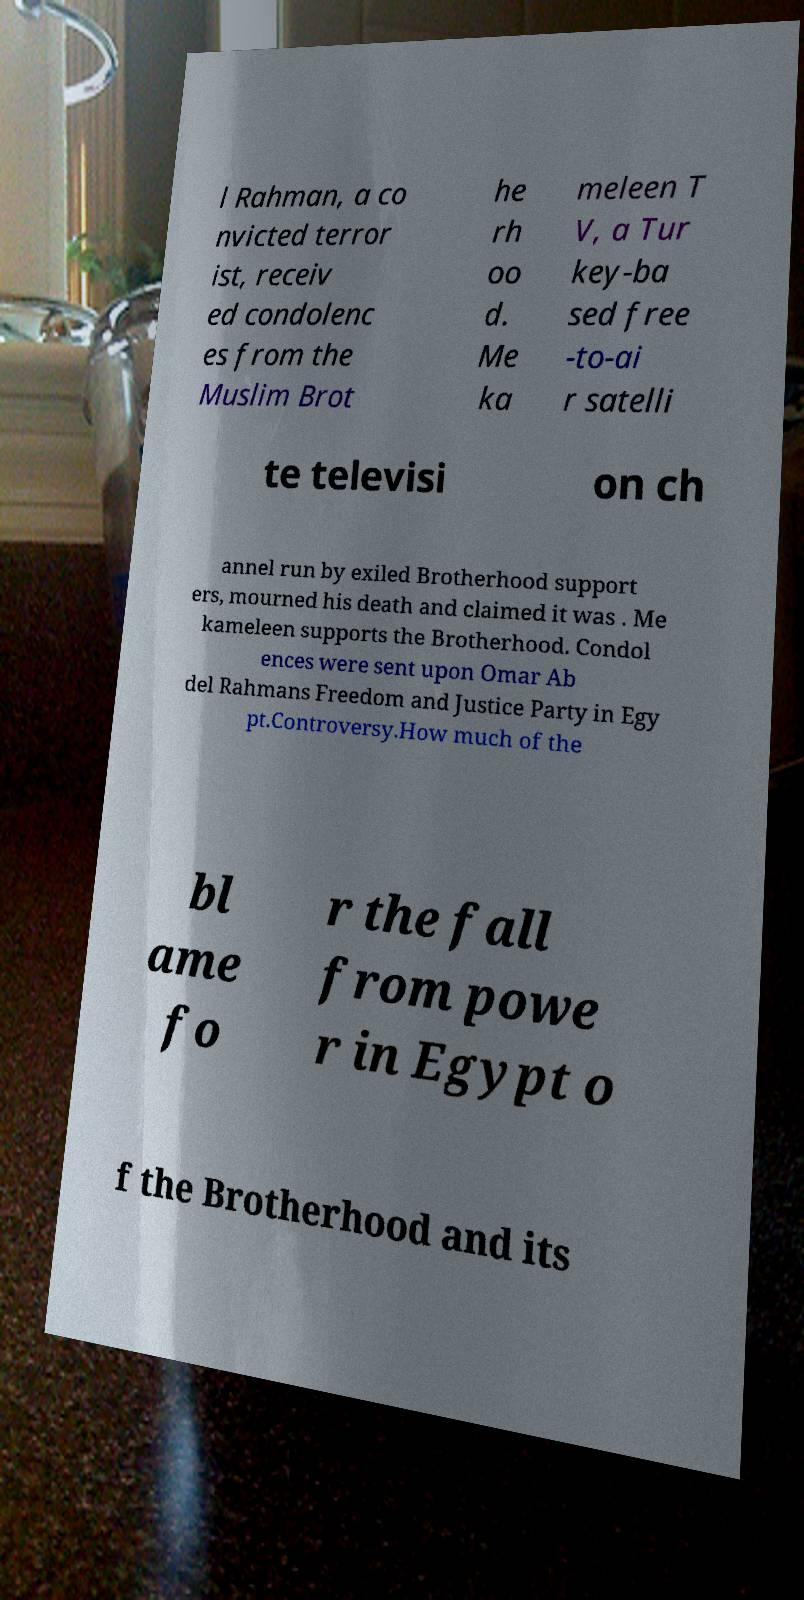There's text embedded in this image that I need extracted. Can you transcribe it verbatim? l Rahman, a co nvicted terror ist, receiv ed condolenc es from the Muslim Brot he rh oo d. Me ka meleen T V, a Tur key-ba sed free -to-ai r satelli te televisi on ch annel run by exiled Brotherhood support ers, mourned his death and claimed it was . Me kameleen supports the Brotherhood. Condol ences were sent upon Omar Ab del Rahmans Freedom and Justice Party in Egy pt.Controversy.How much of the bl ame fo r the fall from powe r in Egypt o f the Brotherhood and its 